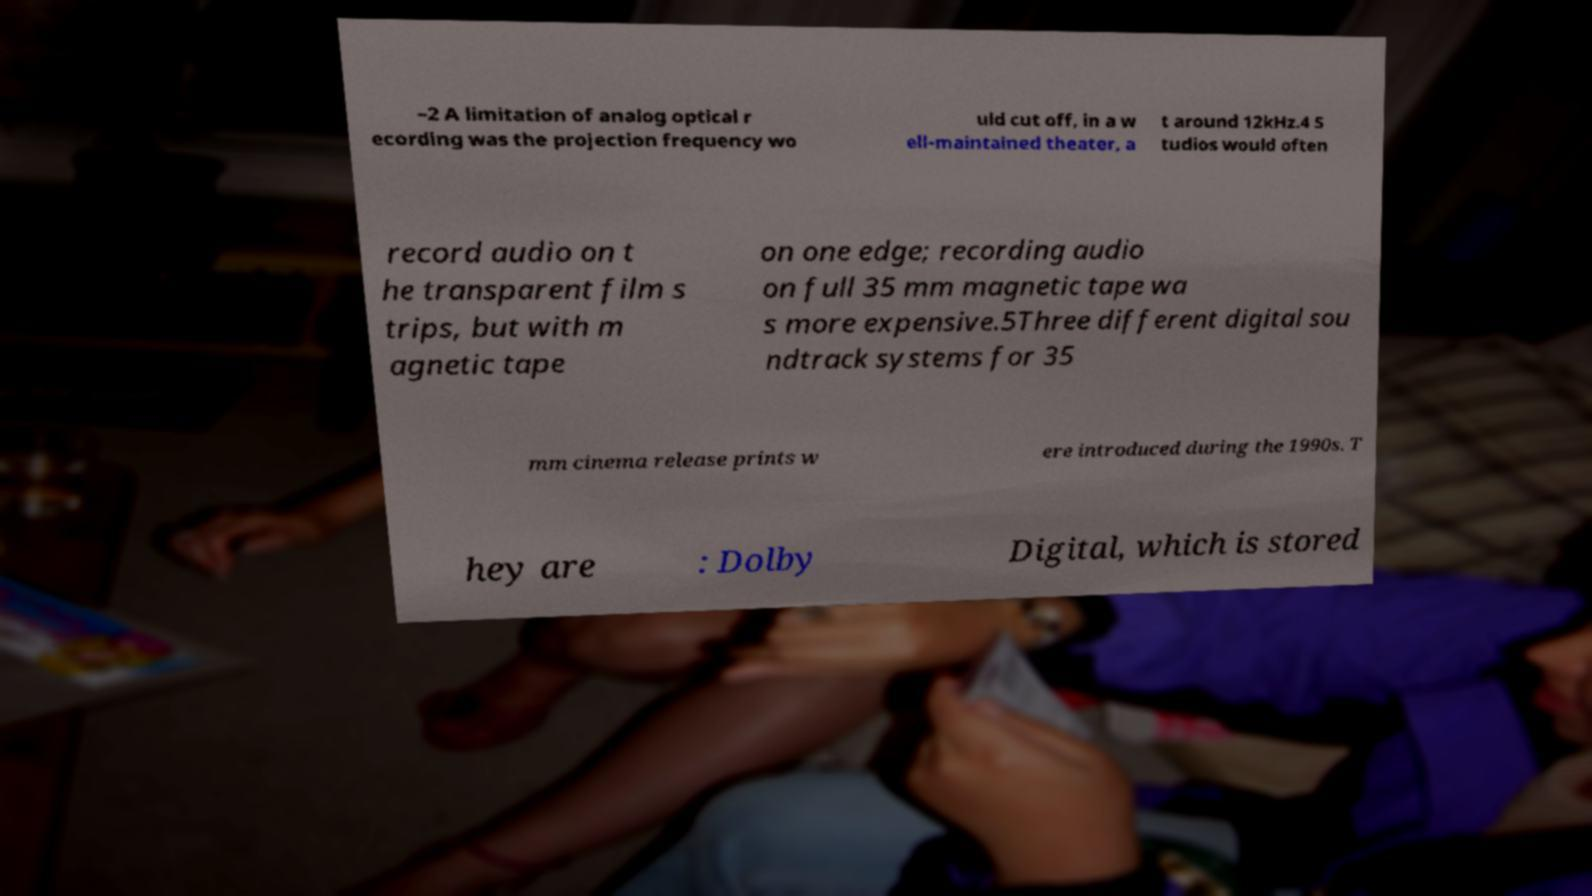Can you accurately transcribe the text from the provided image for me? –2 A limitation of analog optical r ecording was the projection frequency wo uld cut off, in a w ell-maintained theater, a t around 12kHz.4 S tudios would often record audio on t he transparent film s trips, but with m agnetic tape on one edge; recording audio on full 35 mm magnetic tape wa s more expensive.5Three different digital sou ndtrack systems for 35 mm cinema release prints w ere introduced during the 1990s. T hey are : Dolby Digital, which is stored 